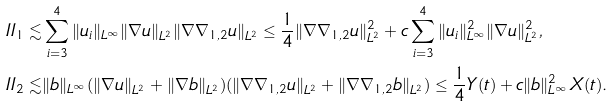Convert formula to latex. <formula><loc_0><loc_0><loc_500><loc_500>I I _ { 1 } \lesssim & \sum _ { i = 3 } ^ { 4 } \| u _ { i } \| _ { L ^ { \infty } } \| \nabla u \| _ { L ^ { 2 } } \| \nabla \nabla _ { 1 , 2 } u \| _ { L ^ { 2 } } \leq \frac { 1 } { 4 } \| \nabla \nabla _ { 1 , 2 } u \| _ { L ^ { 2 } } ^ { 2 } + c \sum _ { i = 3 } ^ { 4 } \| u _ { i } \| _ { L ^ { \infty } } ^ { 2 } \| \nabla u \| _ { L ^ { 2 } } ^ { 2 } , \\ I I _ { 2 } \lesssim & \| b \| _ { L ^ { \infty } } ( \| \nabla u \| _ { L ^ { 2 } } + \| \nabla b \| _ { L ^ { 2 } } ) ( \| \nabla \nabla _ { 1 , 2 } u \| _ { L ^ { 2 } } + \| \nabla \nabla _ { 1 , 2 } b \| _ { L ^ { 2 } } ) \leq \frac { 1 } { 4 } Y ( t ) + c \| b \| _ { L ^ { \infty } } ^ { 2 } X ( t ) .</formula> 